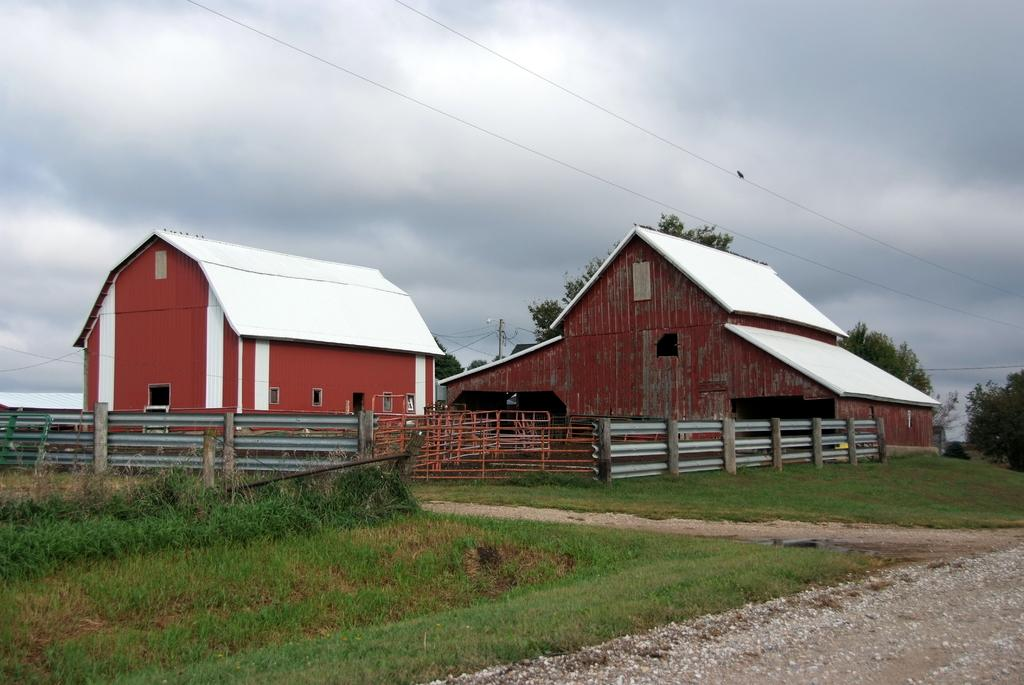What structures are located in the middle of the image? There are houses in the middle of the image. What type of vegetation is at the bottom of the image? Plants and grass are present at the bottom of the image. What architectural features can be seen in the image? There is a railing and a fence in the image. What type of land is visible in the image? There is land visible in the image. What is present at the top of the image? Cables, trees, poles, and the sky are visible at the top of the image. What can be seen in the sky? Clouds are present in the sky. What type of frame is used to hold the jellyfish in the image? There are no jellyfish present in the image. What rhythm does the music have in the image? There is no music or rhythm present in the image. 